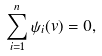<formula> <loc_0><loc_0><loc_500><loc_500>\sum _ { i = 1 } ^ { n } \psi _ { i } ( v ) = 0 ,</formula> 